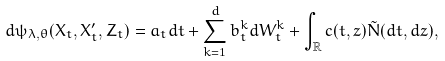<formula> <loc_0><loc_0><loc_500><loc_500>d \psi _ { \lambda , \theta } ( X _ { t } , X ^ { \prime } _ { t } , Z _ { t } ) = a _ { t } d t + \sum _ { k = 1 } ^ { d } b ^ { k } _ { t } d W ^ { k } _ { t } + \int _ { \mathbb { R } } c ( t , z ) \tilde { N } ( d t , d z ) ,</formula> 